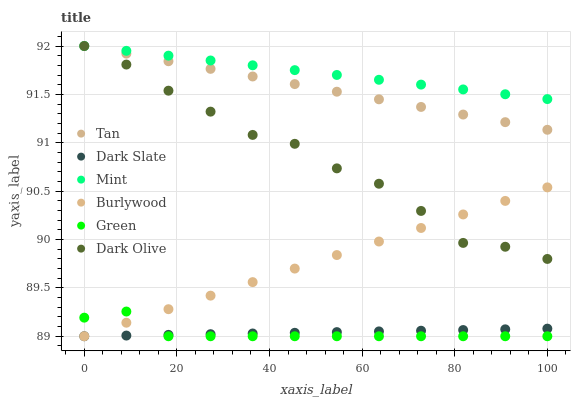Does Green have the minimum area under the curve?
Answer yes or no. Yes. Does Mint have the maximum area under the curve?
Answer yes or no. Yes. Does Dark Olive have the minimum area under the curve?
Answer yes or no. No. Does Dark Olive have the maximum area under the curve?
Answer yes or no. No. Is Dark Slate the smoothest?
Answer yes or no. Yes. Is Dark Olive the roughest?
Answer yes or no. Yes. Is Dark Olive the smoothest?
Answer yes or no. No. Is Dark Slate the roughest?
Answer yes or no. No. Does Burlywood have the lowest value?
Answer yes or no. Yes. Does Dark Olive have the lowest value?
Answer yes or no. No. Does Mint have the highest value?
Answer yes or no. Yes. Does Dark Slate have the highest value?
Answer yes or no. No. Is Dark Slate less than Tan?
Answer yes or no. Yes. Is Mint greater than Green?
Answer yes or no. Yes. Does Green intersect Burlywood?
Answer yes or no. Yes. Is Green less than Burlywood?
Answer yes or no. No. Is Green greater than Burlywood?
Answer yes or no. No. Does Dark Slate intersect Tan?
Answer yes or no. No. 